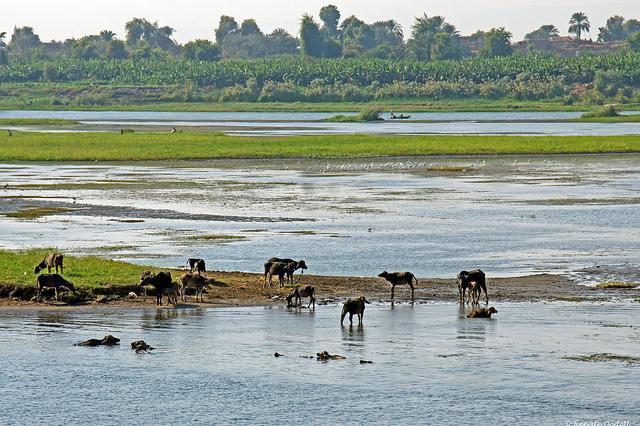How many white horses are pulling the carriage?
Give a very brief answer. 0. 